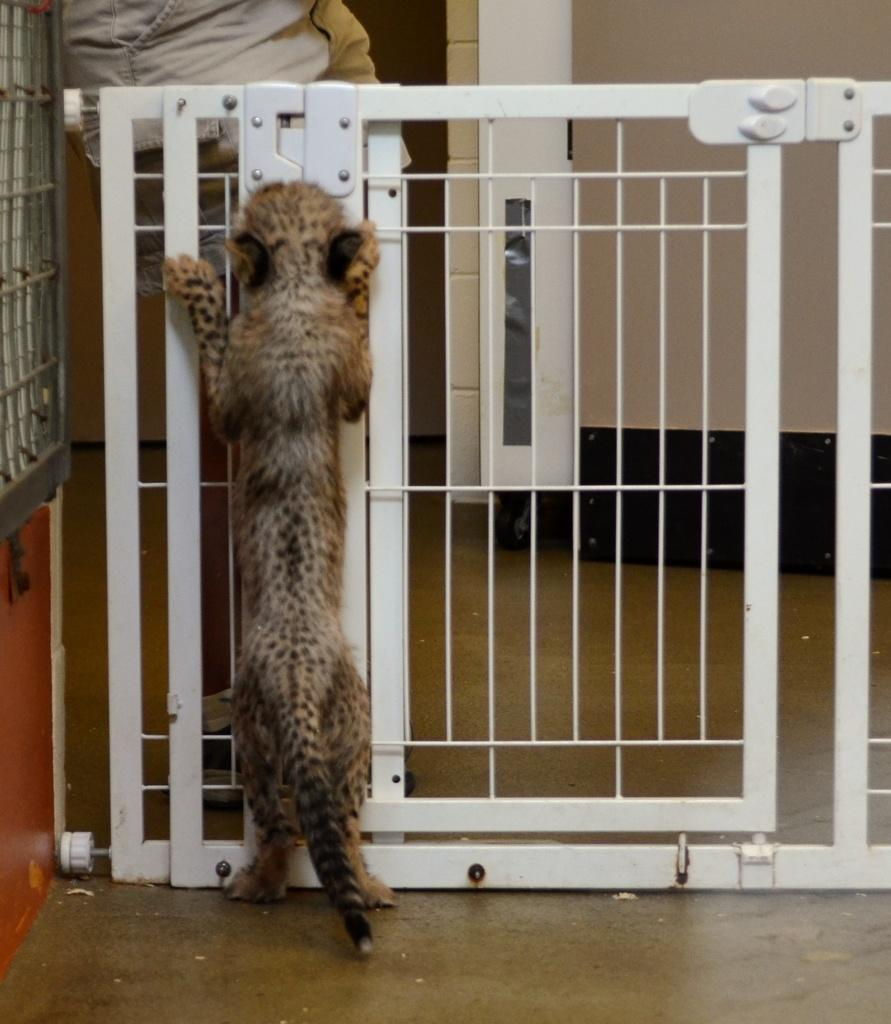What type of animal is in the image? There is an animal in the image, but the specific type cannot be determined from the provided facts. What is the animal's location in relation to the grille? The animal is near a grille in the image. Who else is present in the image? There is a person in the image. Where is the person standing in relation to the animal and the grille? The person is standing on the other side of the grille in the image. What can be seen in the background of the image? There is a wall in the background of the image. How many bikes are parked in front of the wall in the image? There is no mention of bikes in the provided facts, so it cannot be determined how many bikes are present in the image. 